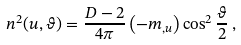Convert formula to latex. <formula><loc_0><loc_0><loc_500><loc_500>n ^ { 2 } ( u , \vartheta ) = \frac { D - 2 } { 4 \pi } \left ( - m _ { , u } \right ) \cos ^ { 2 } \frac { \vartheta } { 2 } \, ,</formula> 